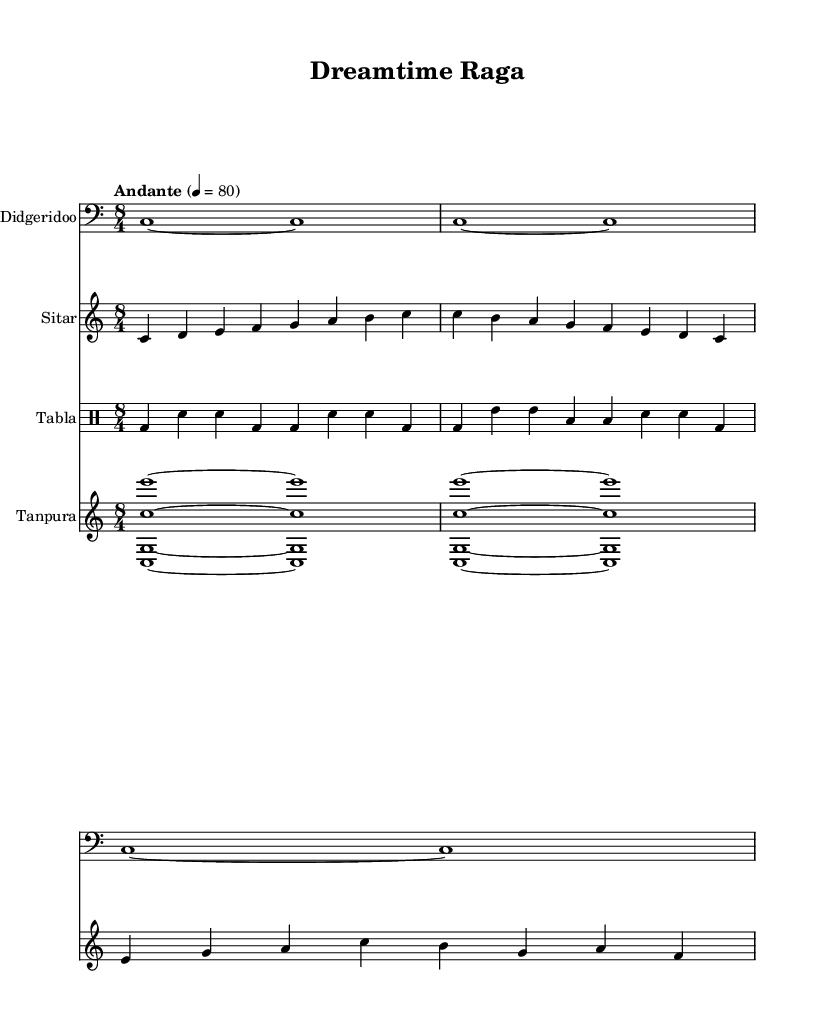What is the key signature of this music? The key signature is C major, which has no sharps or flats.
Answer: C major What is the time signature of the piece? The time signature is indicated as 8/4, meaning there are eight beats per measure.
Answer: 8/4 What is the tempo marking of the composition? The tempo marking indicates "Andante" at a speed of 80 beats per minute.
Answer: Andante How many instruments are included in the score? There are four instruments listed: Didgeridoo, Sitar, Tabla, and Tanpura.
Answer: Four Which instrument is playing in the bass clef? The Didgeridoo part is written in the bass clef, indicating it plays the lower range.
Answer: Didgeridoo What rhythmic pattern does the Tabla follow? The Tabla follows a rhythmic pattern that combines bass drum (bd) and snare (sn) sounds, creating a traditional Indian percussion feel.
Answer: Bass and snare How does the Didgeridoo part contribute to the overall fusion of styles in the music? The Didgeridoo plays long, sustained notes that create a drone effect, complementing the melodic lines of the Sitar and enhancing the texture of Indian raga and Aboriginal elements.
Answer: Drone effect 